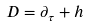Convert formula to latex. <formula><loc_0><loc_0><loc_500><loc_500>D = \partial _ { \tau } + h</formula> 